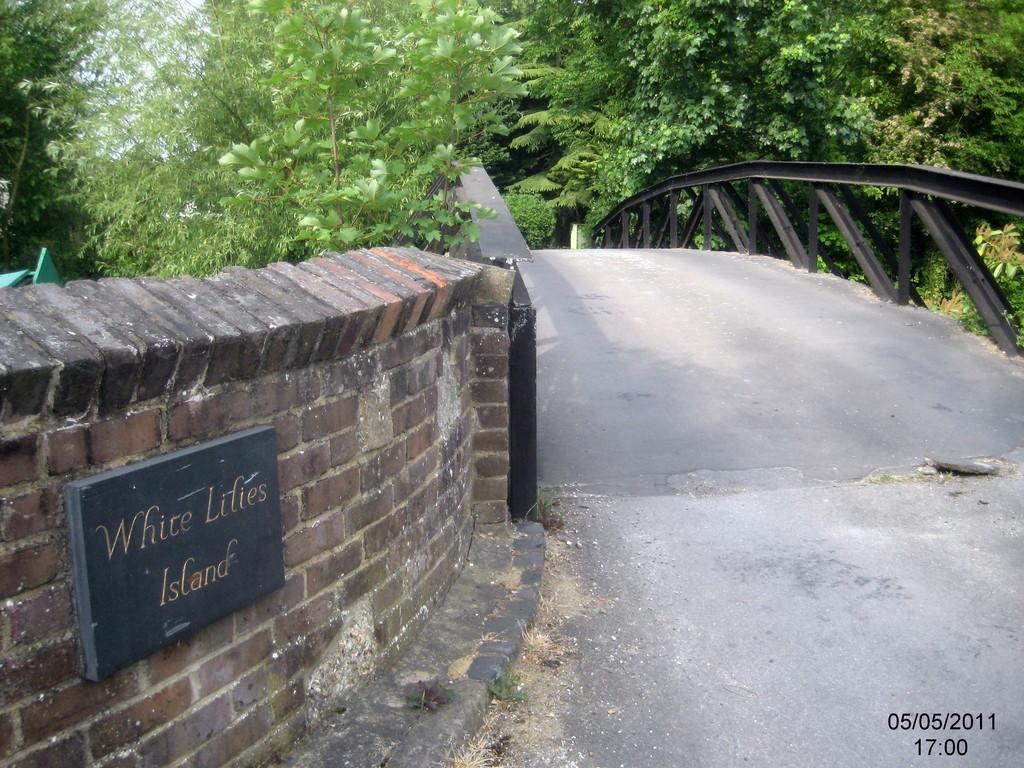Can you describe this image briefly? In the picture we can see a brick wall on it, we can see a board written on it as white lilies island and beside it, we can see a pathway with railings on the both sides and behind the railings we can see full of plants and trees. 